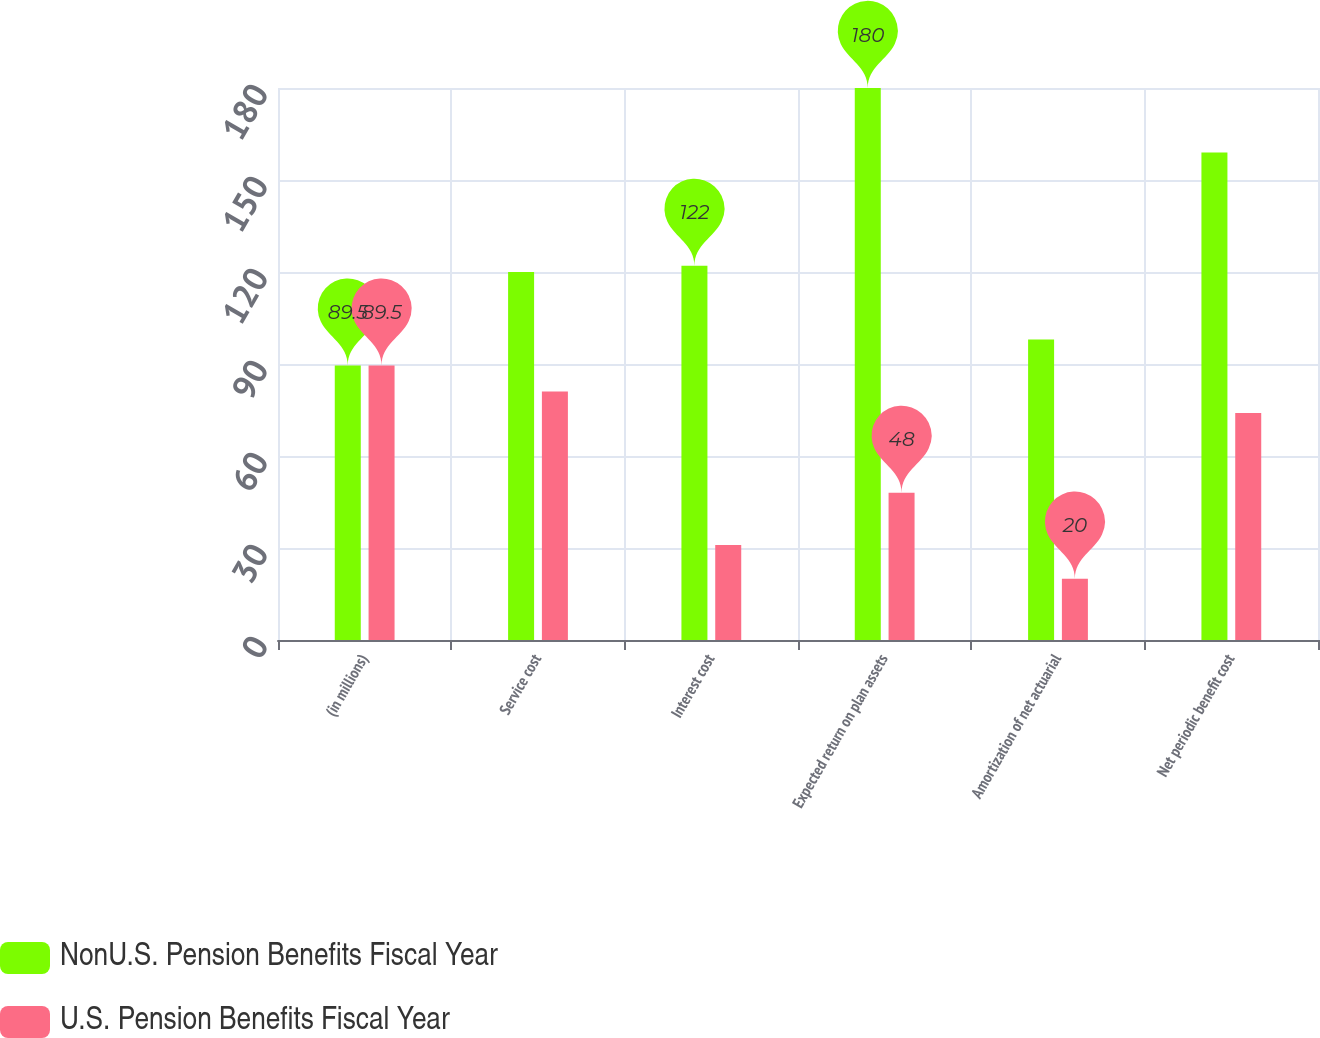Convert chart. <chart><loc_0><loc_0><loc_500><loc_500><stacked_bar_chart><ecel><fcel>(in millions)<fcel>Service cost<fcel>Interest cost<fcel>Expected return on plan assets<fcel>Amortization of net actuarial<fcel>Net periodic benefit cost<nl><fcel>NonU.S. Pension Benefits Fiscal Year<fcel>89.5<fcel>120<fcel>122<fcel>180<fcel>98<fcel>159<nl><fcel>U.S. Pension Benefits Fiscal Year<fcel>89.5<fcel>81<fcel>31<fcel>48<fcel>20<fcel>74<nl></chart> 